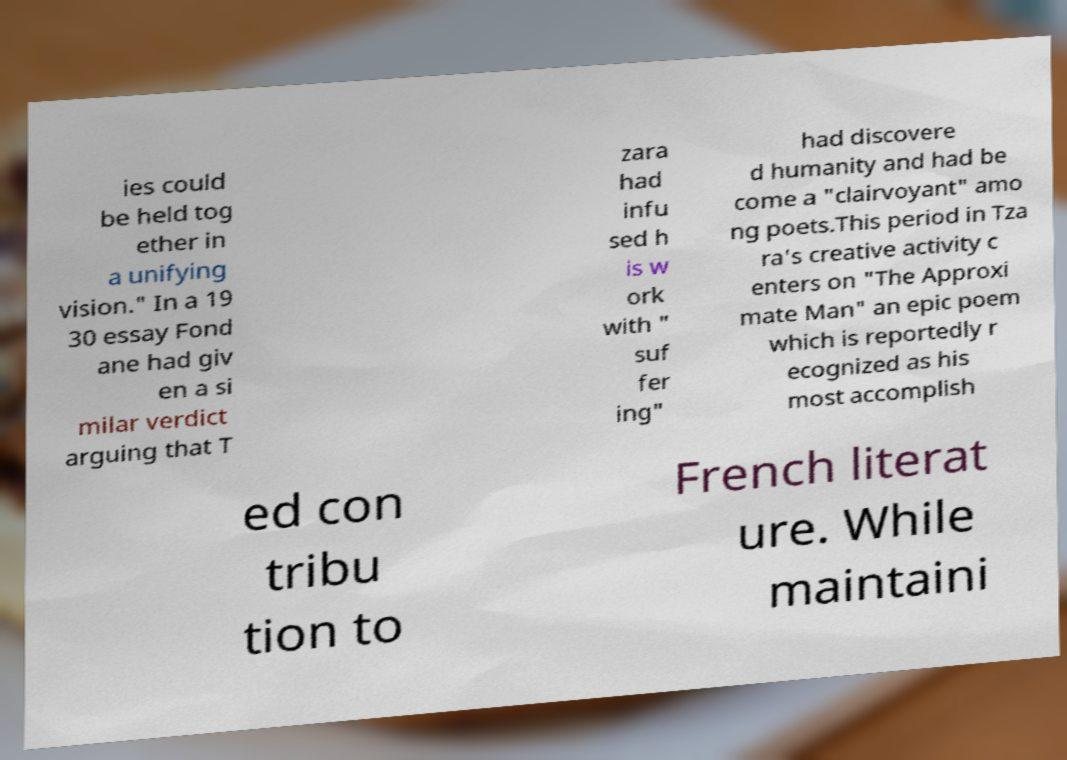I need the written content from this picture converted into text. Can you do that? ies could be held tog ether in a unifying vision." In a 19 30 essay Fond ane had giv en a si milar verdict arguing that T zara had infu sed h is w ork with " suf fer ing" had discovere d humanity and had be come a "clairvoyant" amo ng poets.This period in Tza ra's creative activity c enters on "The Approxi mate Man" an epic poem which is reportedly r ecognized as his most accomplish ed con tribu tion to French literat ure. While maintaini 